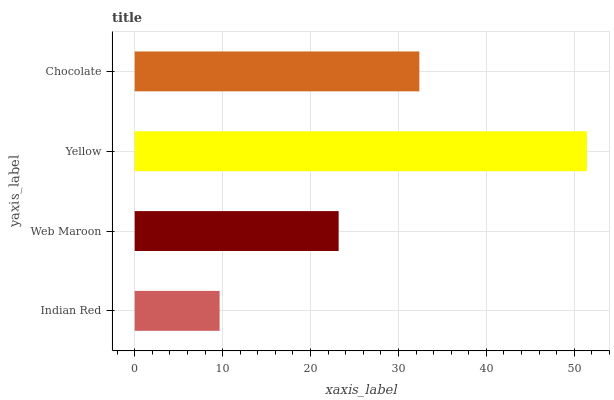Is Indian Red the minimum?
Answer yes or no. Yes. Is Yellow the maximum?
Answer yes or no. Yes. Is Web Maroon the minimum?
Answer yes or no. No. Is Web Maroon the maximum?
Answer yes or no. No. Is Web Maroon greater than Indian Red?
Answer yes or no. Yes. Is Indian Red less than Web Maroon?
Answer yes or no. Yes. Is Indian Red greater than Web Maroon?
Answer yes or no. No. Is Web Maroon less than Indian Red?
Answer yes or no. No. Is Chocolate the high median?
Answer yes or no. Yes. Is Web Maroon the low median?
Answer yes or no. Yes. Is Web Maroon the high median?
Answer yes or no. No. Is Yellow the low median?
Answer yes or no. No. 